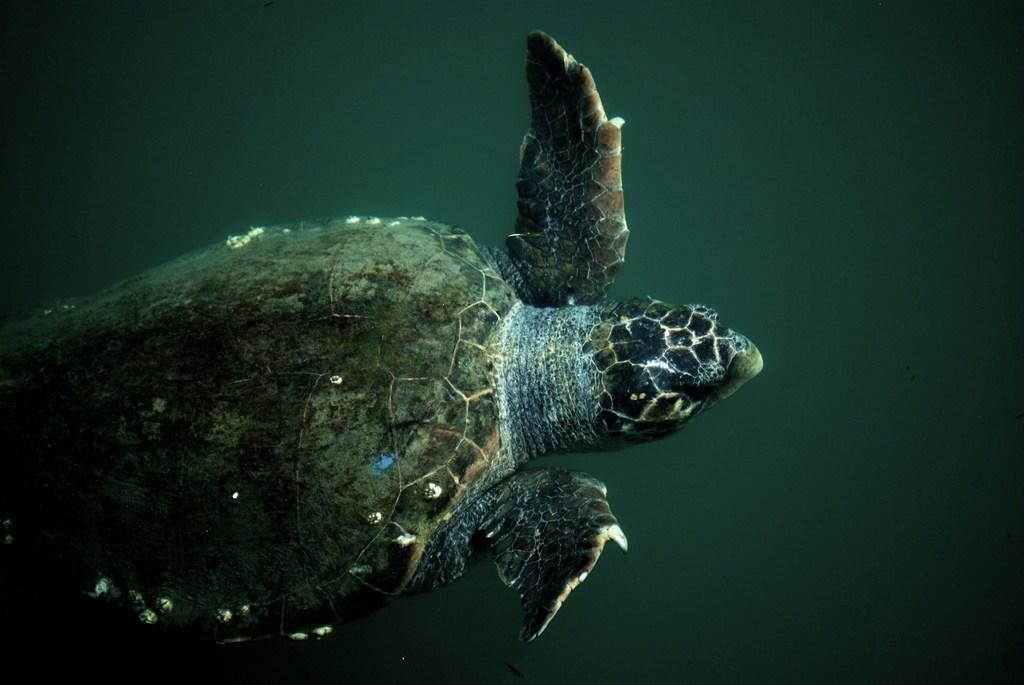What animal is present in the image? There is a turtle in the image. What type of environment is depicted in the image? There appears to be water at the bottom of the image. What type of weather can be seen in the image? There is no indication of weather in the image, as it only features a turtle in water. How many passengers are visible in the image? There are no passengers present in the image. 